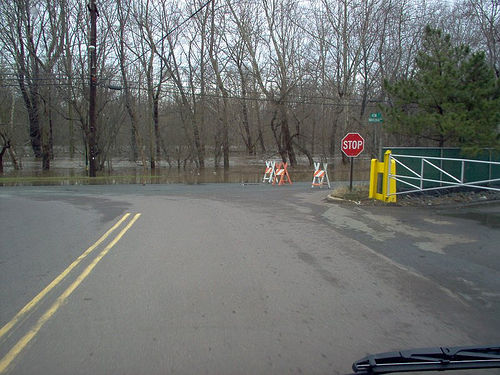<image>What state is on the sign? There is no state name on the sign. What state is on the sign? The sign does not have any state name on it. 